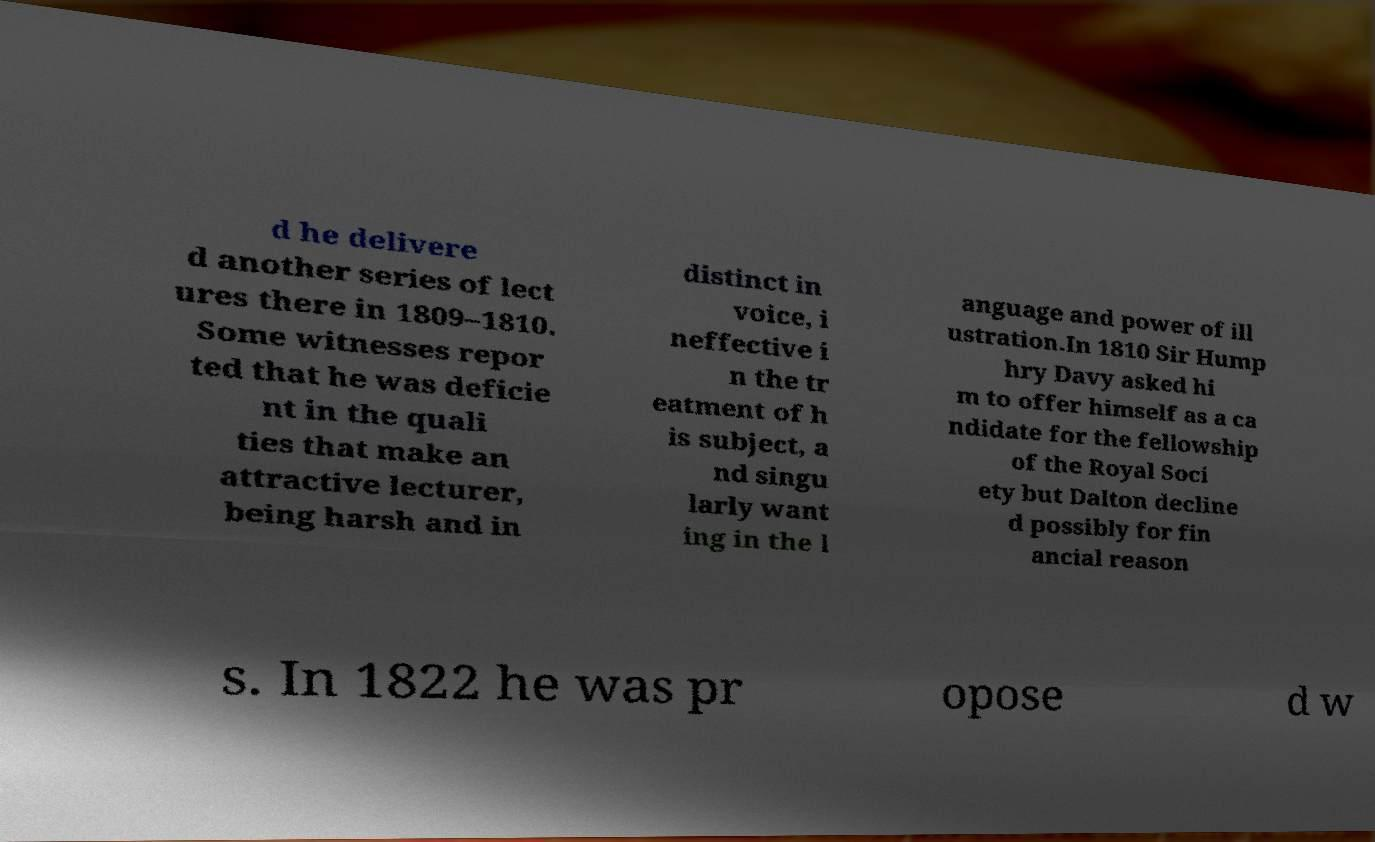Please read and relay the text visible in this image. What does it say? d he delivere d another series of lect ures there in 1809–1810. Some witnesses repor ted that he was deficie nt in the quali ties that make an attractive lecturer, being harsh and in distinct in voice, i neffective i n the tr eatment of h is subject, a nd singu larly want ing in the l anguage and power of ill ustration.In 1810 Sir Hump hry Davy asked hi m to offer himself as a ca ndidate for the fellowship of the Royal Soci ety but Dalton decline d possibly for fin ancial reason s. In 1822 he was pr opose d w 